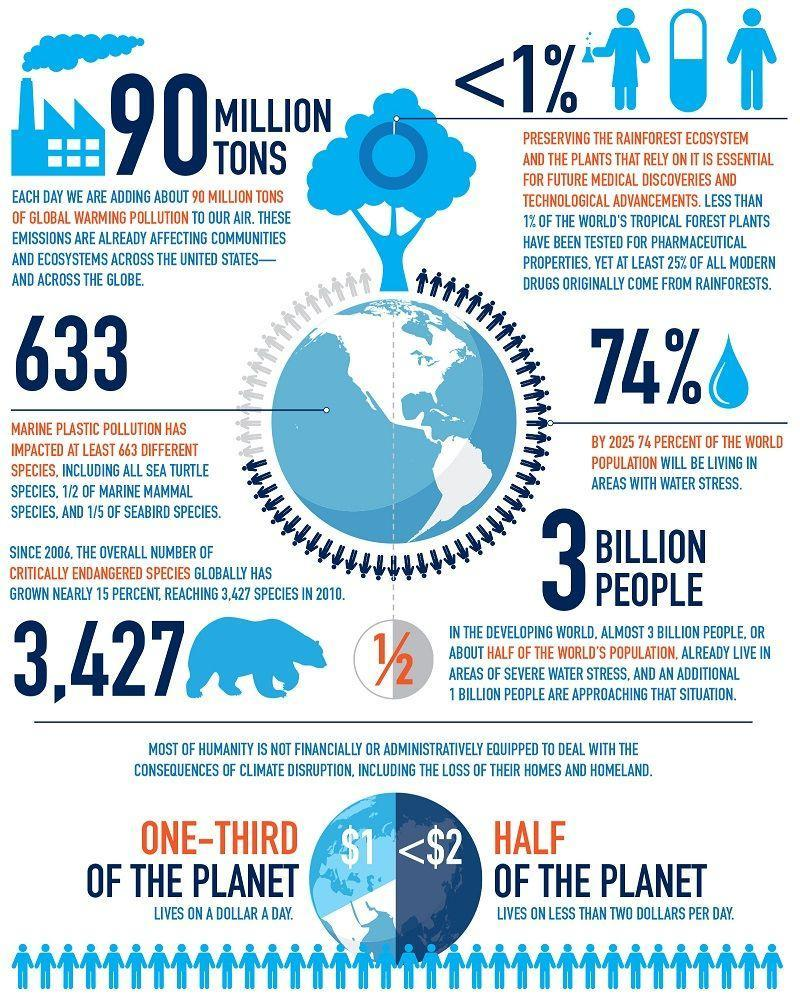What percentage of  people across the global earn less than $2 per day?
Answer the question with a short phrase. 50% What percentage of people around the world earn $1 per day? 33.33% 